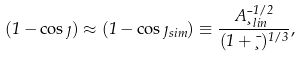<formula> <loc_0><loc_0><loc_500><loc_500>( 1 - \cos \eta ) \approx ( 1 - \cos \eta _ { s i m } ) \equiv \frac { A \bar { \xi } _ { l i n } ^ { 1 / 2 } } { ( 1 + \bar { \xi } ) ^ { 1 / 3 } } ,</formula> 